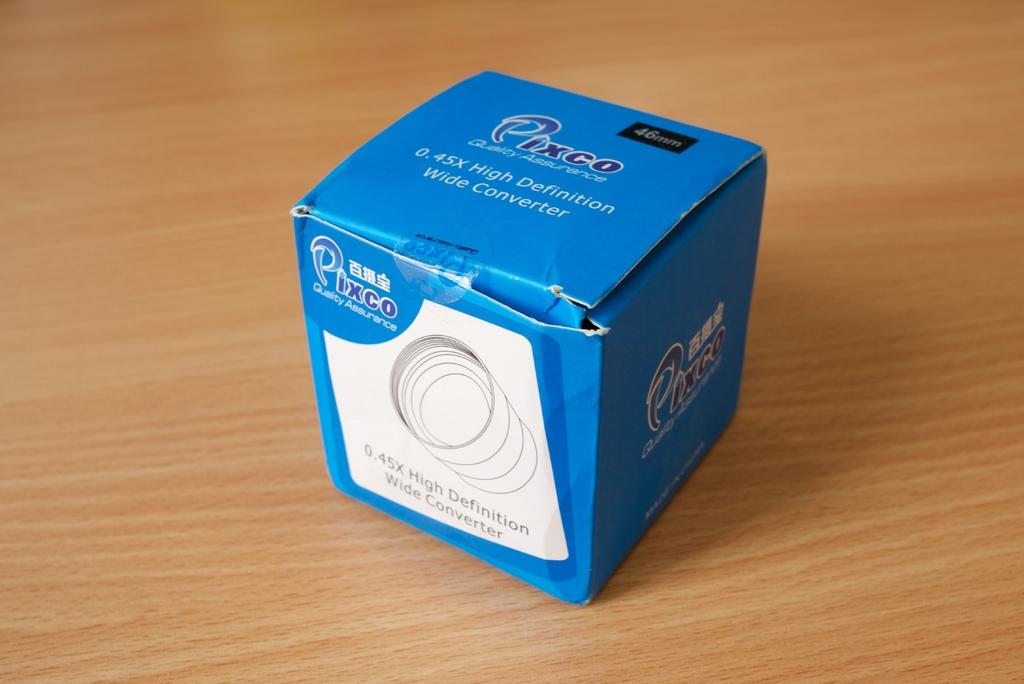What type of converter is in this box?
Offer a very short reply. High definition wide converter. What is the brand?
Ensure brevity in your answer.  Pixco. 